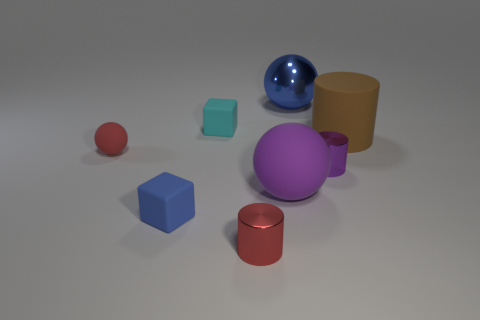Subtract all balls. How many objects are left? 5 Add 1 purple cylinders. How many objects exist? 9 Add 1 small red cylinders. How many small red cylinders are left? 2 Add 8 gray rubber cubes. How many gray rubber cubes exist? 8 Subtract 1 brown cylinders. How many objects are left? 7 Subtract all large blue rubber blocks. Subtract all small blue rubber cubes. How many objects are left? 7 